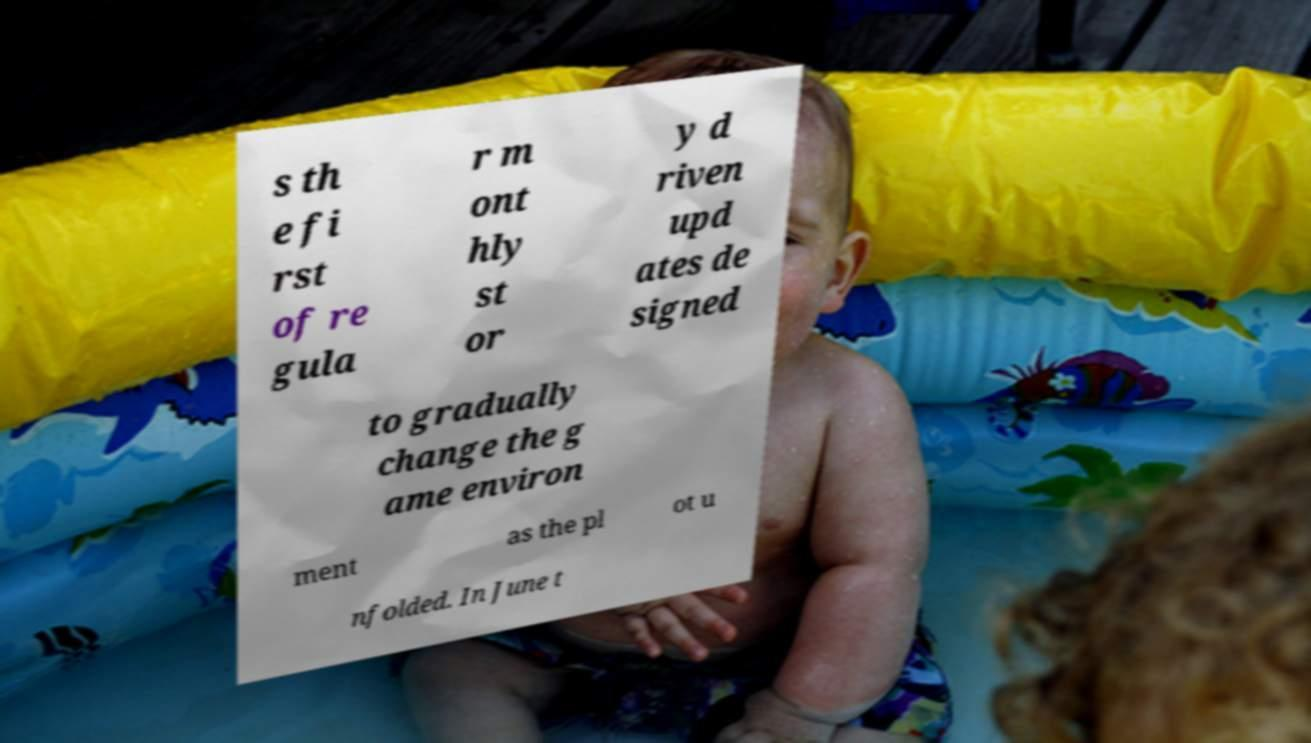What messages or text are displayed in this image? I need them in a readable, typed format. s th e fi rst of re gula r m ont hly st or y d riven upd ates de signed to gradually change the g ame environ ment as the pl ot u nfolded. In June t 